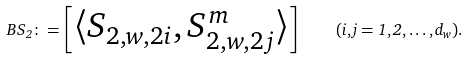<formula> <loc_0><loc_0><loc_500><loc_500>\ B S _ { 2 } \colon = \begin{bmatrix} \langle S _ { 2 , w , { 2 i } } , S _ { 2 , w , { 2 j } } ^ { m } \rangle \end{bmatrix} \quad ( i , j = 1 , 2 , \dots , d _ { w } ) .</formula> 